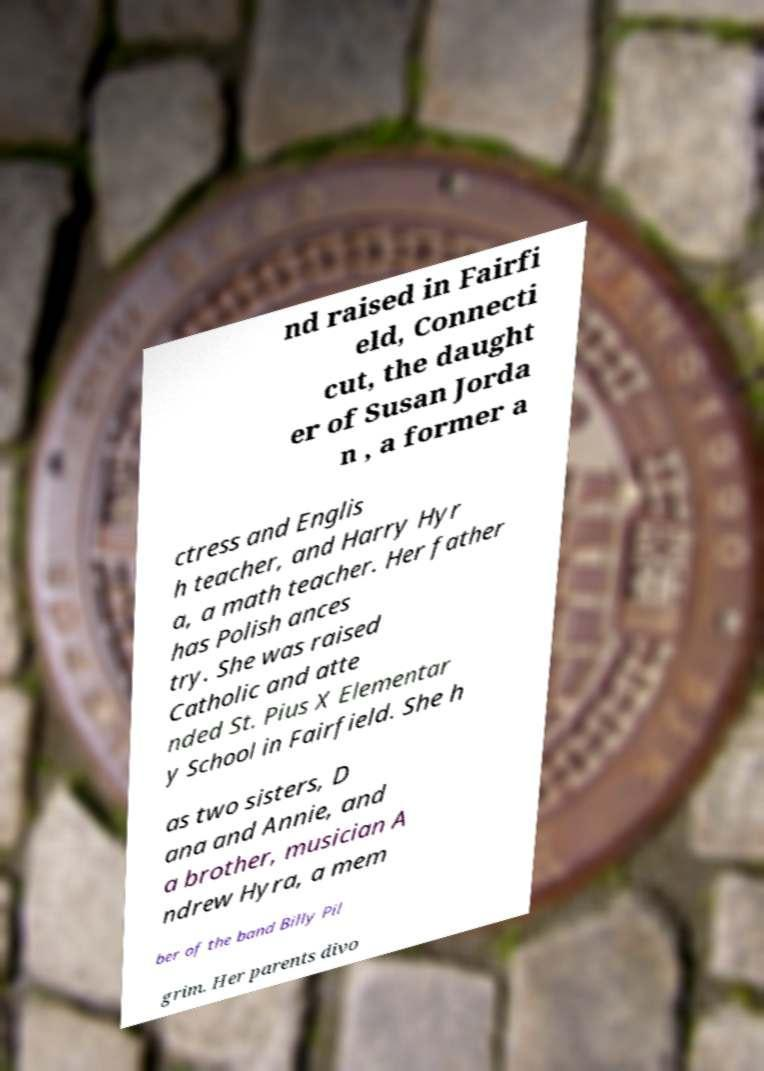For documentation purposes, I need the text within this image transcribed. Could you provide that? nd raised in Fairfi eld, Connecti cut, the daught er of Susan Jorda n , a former a ctress and Englis h teacher, and Harry Hyr a, a math teacher. Her father has Polish ances try. She was raised Catholic and atte nded St. Pius X Elementar y School in Fairfield. She h as two sisters, D ana and Annie, and a brother, musician A ndrew Hyra, a mem ber of the band Billy Pil grim. Her parents divo 